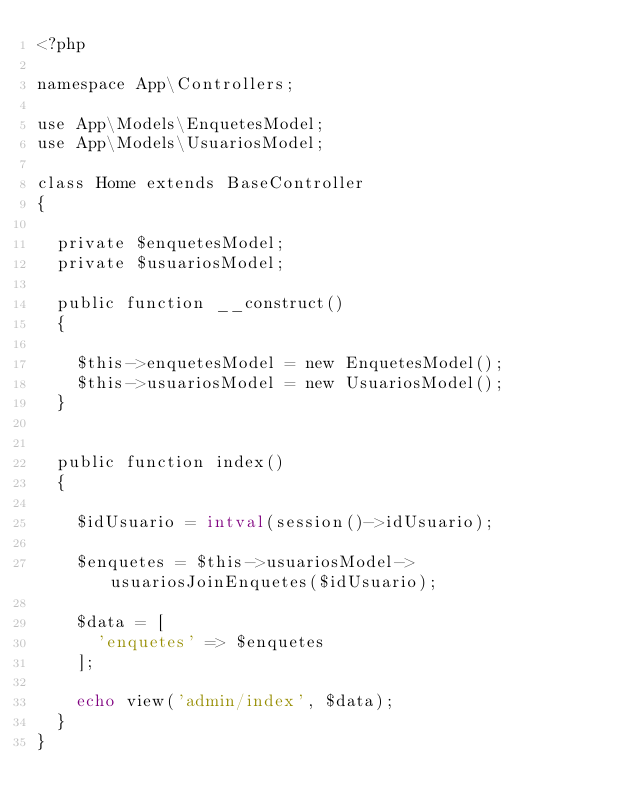<code> <loc_0><loc_0><loc_500><loc_500><_PHP_><?php

namespace App\Controllers;

use App\Models\EnquetesModel;
use App\Models\UsuariosModel;

class Home extends BaseController
{

	private $enquetesModel;
	private $usuariosModel;

	public function __construct()
	{

		$this->enquetesModel = new EnquetesModel();
		$this->usuariosModel = new UsuariosModel();
	}


	public function index()
	{

		$idUsuario = intval(session()->idUsuario);

		$enquetes = $this->usuariosModel->usuariosJoinEnquetes($idUsuario);

		$data = [
			'enquetes' => $enquetes
		];

		echo view('admin/index', $data);
	}
}
</code> 